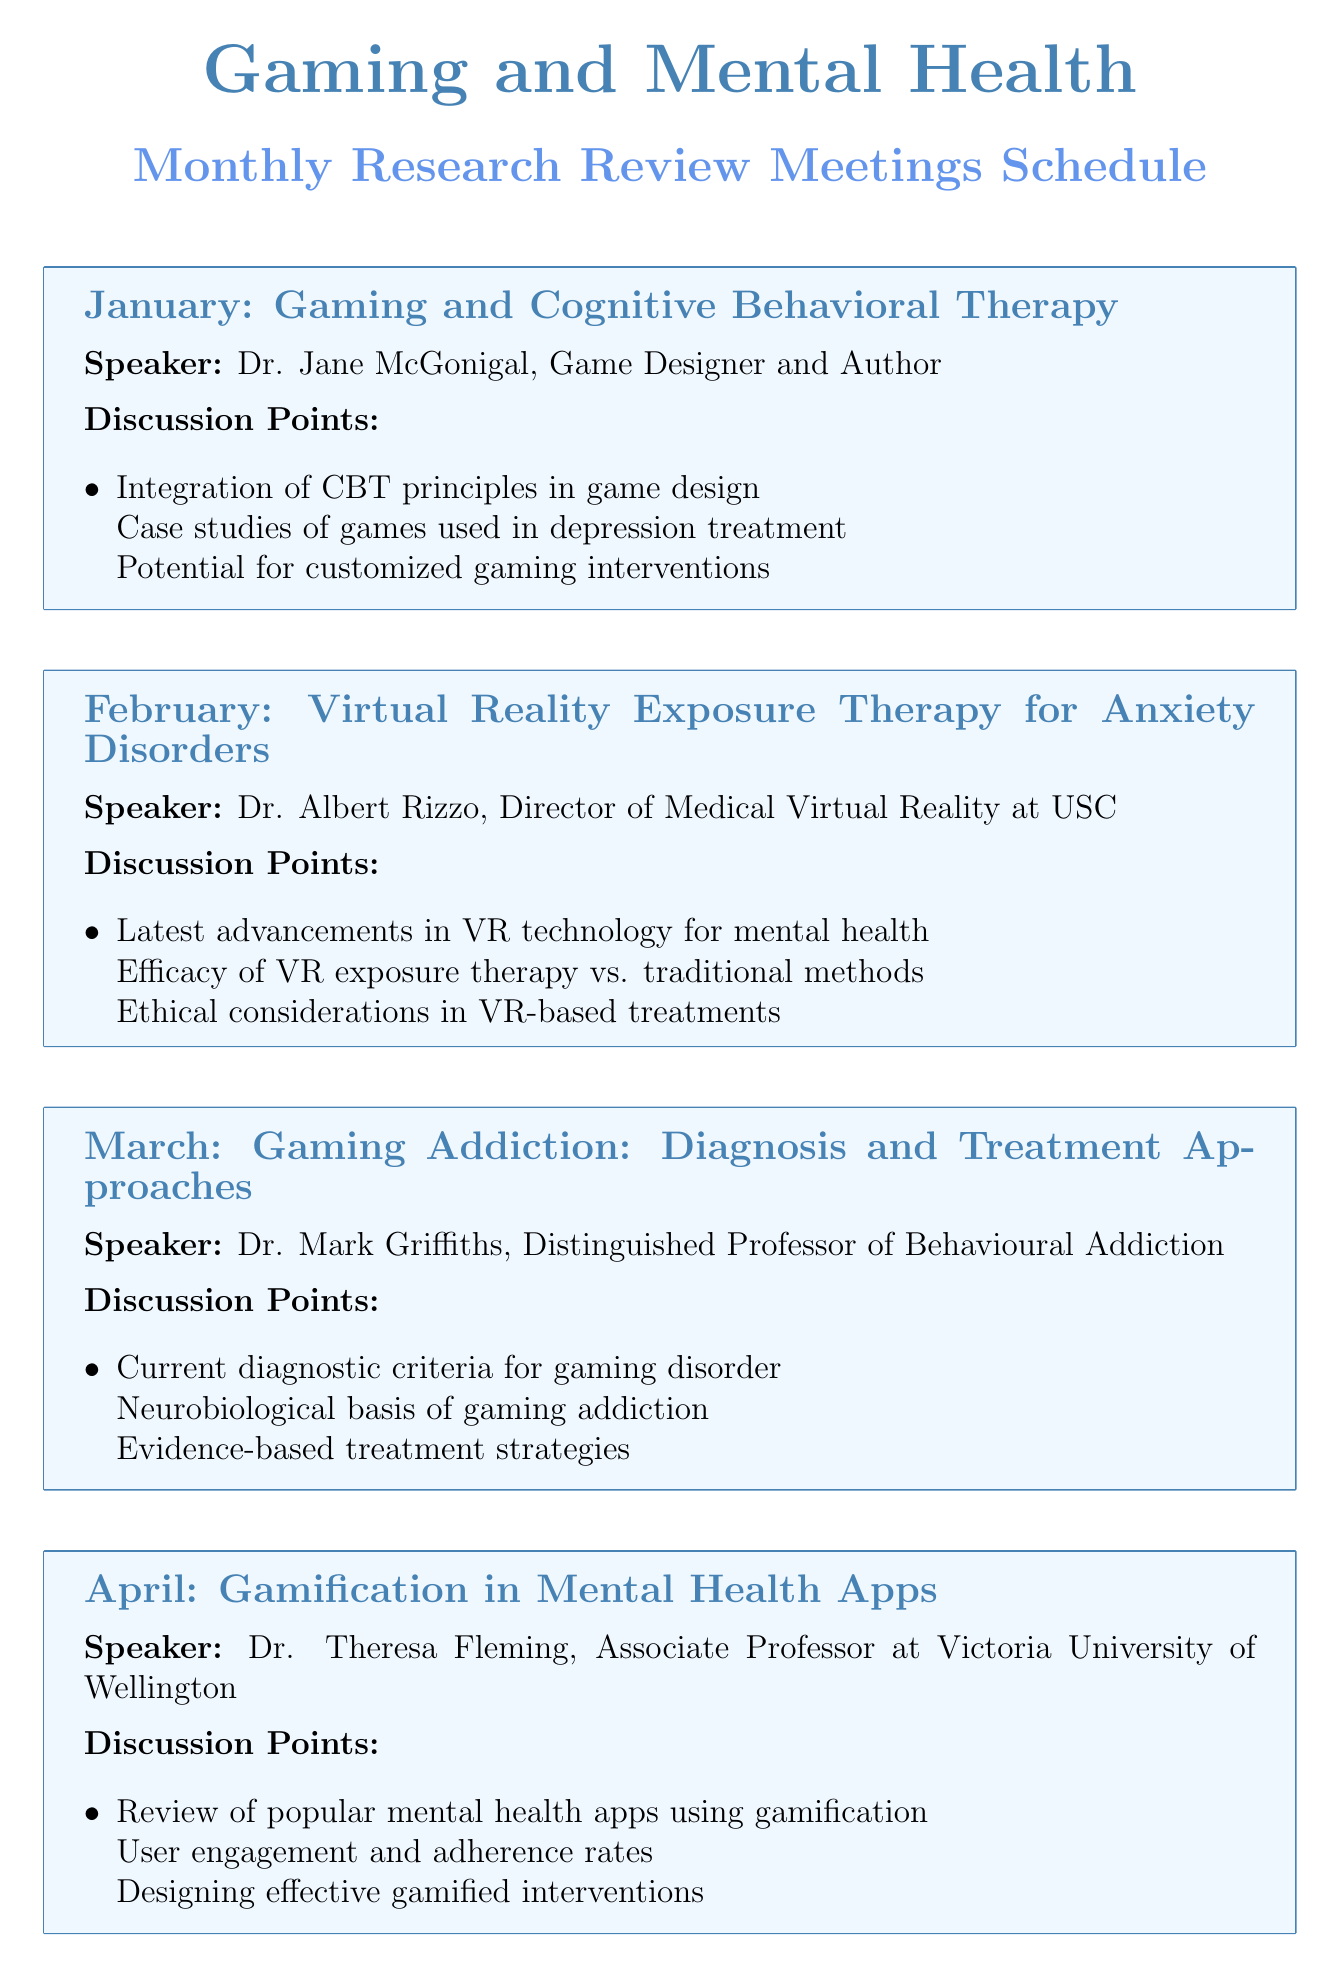What is the topic of the January meeting? The topic is listed clearly under the January meeting heading in the document.
Answer: Gaming and Cognitive Behavioral Therapy Who is the speaker for the June meeting? Each meeting specifies a speaker, and the June meeting lists Dr. Matthew Goodwin as the speaker.
Answer: Dr. Matthew Goodwin What key area is discussed in the October meeting? The document details discussion points for each meeting, with the October meeting focusing on cognitive training for schizophrenia.
Answer: Gaming-Based Cognitive Training for Schizophrenia Which month addresses gaming addiction? The month associated with gaming addiction is indicated in the meeting schedule under its respective topic.
Answer: March How many meetings focus on PTSD? The document includes meetings, and by reviewing the topics, we can count the relevant meetings focused on PTSD.
Answer: 2 What is the main focus of Dr. Ian Bogost's discussion in November? The document outlines the discussion focus under each speaker's segment, specifically indicating narrative-based games.
Answer: Narrative-Based Games for Emotional Regulation In which month is the annual review scheduled? The schedule clearly indicates the final month's topic as the annual review of gaming in mental health treatment.
Answer: December What is the discussion point for the April meeting? Each meeting includes discussion points, and the April meeting mentions gamification in mental health apps specifically.
Answer: Gamification in Mental Health Apps 